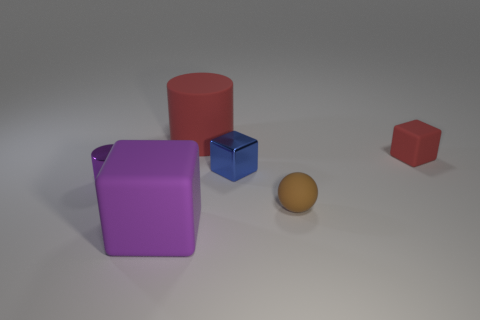Subtract all small rubber blocks. How many blocks are left? 2 Subtract all blue cubes. How many cubes are left? 2 Subtract all balls. How many objects are left? 5 Subtract 1 blocks. How many blocks are left? 2 Subtract 0 green spheres. How many objects are left? 6 Subtract all purple cylinders. Subtract all brown cubes. How many cylinders are left? 1 Subtract all purple cubes. How many red cylinders are left? 1 Subtract all gray shiny objects. Subtract all big cubes. How many objects are left? 5 Add 4 purple rubber things. How many purple rubber things are left? 5 Add 2 big red rubber cubes. How many big red rubber cubes exist? 2 